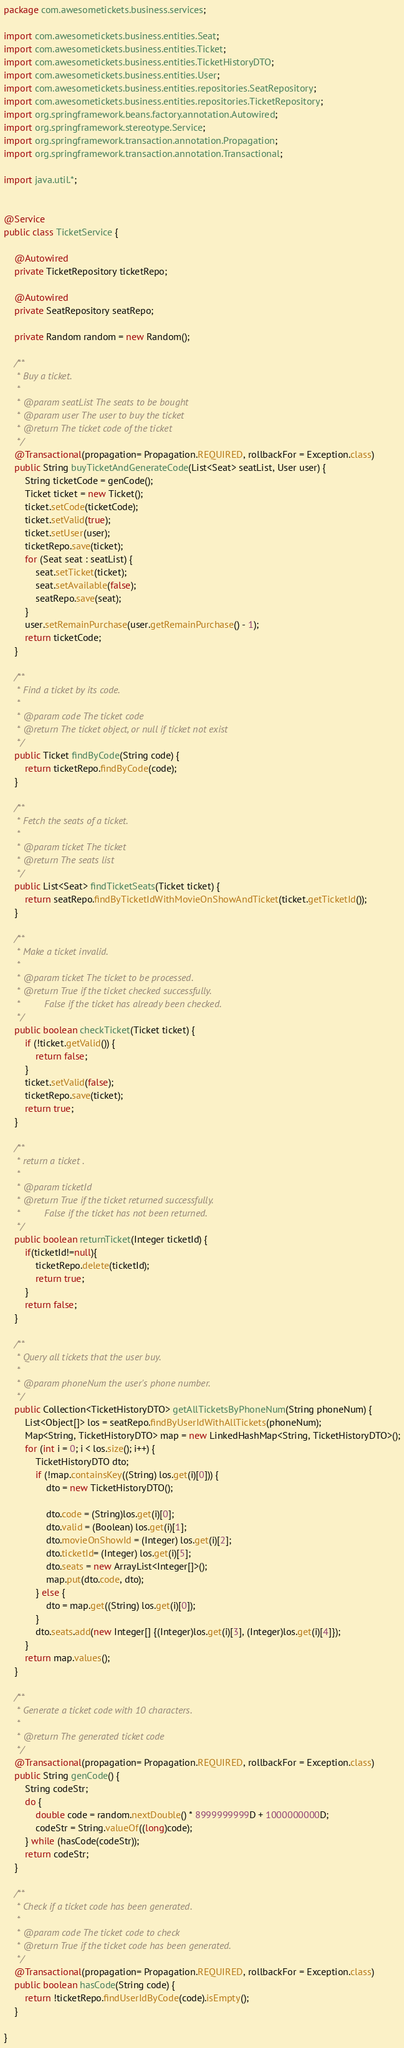Convert code to text. <code><loc_0><loc_0><loc_500><loc_500><_Java_>package com.awesometickets.business.services;

import com.awesometickets.business.entities.Seat;
import com.awesometickets.business.entities.Ticket;
import com.awesometickets.business.entities.TicketHistoryDTO;
import com.awesometickets.business.entities.User;
import com.awesometickets.business.entities.repositories.SeatRepository;
import com.awesometickets.business.entities.repositories.TicketRepository;
import org.springframework.beans.factory.annotation.Autowired;
import org.springframework.stereotype.Service;
import org.springframework.transaction.annotation.Propagation;
import org.springframework.transaction.annotation.Transactional;

import java.util.*;


@Service
public class TicketService {

    @Autowired
    private TicketRepository ticketRepo;

    @Autowired
    private SeatRepository seatRepo;

    private Random random = new Random();

    /**
     * Buy a ticket.
     *
     * @param seatList The seats to be bought
     * @param user The user to buy the ticket
     * @return The ticket code of the ticket
     */
    @Transactional(propagation= Propagation.REQUIRED, rollbackFor = Exception.class)
    public String buyTicketAndGenerateCode(List<Seat> seatList, User user) {
        String ticketCode = genCode();
        Ticket ticket = new Ticket();
        ticket.setCode(ticketCode);
        ticket.setValid(true);
        ticket.setUser(user);
        ticketRepo.save(ticket);
        for (Seat seat : seatList) {
            seat.setTicket(ticket);
            seat.setAvailable(false);
            seatRepo.save(seat);
        }
        user.setRemainPurchase(user.getRemainPurchase() - 1);
        return ticketCode;
    }

    /**
     * Find a ticket by its code.
     *
     * @param code The ticket code
     * @return The ticket object, or null if ticket not exist
     */
    public Ticket findByCode(String code) {
        return ticketRepo.findByCode(code);
    }

    /**
     * Fetch the seats of a ticket.
     *
     * @param ticket The ticket
     * @return The seats list
     */
    public List<Seat> findTicketSeats(Ticket ticket) {
        return seatRepo.findByTicketIdWithMovieOnShowAndTicket(ticket.getTicketId());
    }

    /**
     * Make a ticket invalid.
     *
     * @param ticket The ticket to be processed.
     * @return True if the ticket checked successfully.
     *         False if the ticket has already been checked.
     */
    public boolean checkTicket(Ticket ticket) {
        if (!ticket.getValid()) {
            return false;
        }
        ticket.setValid(false);
        ticketRepo.save(ticket);
        return true;
    }

    /**
     * return a ticket .
     *
     * @param ticketId
     * @return True if the ticket returned successfully.
     *         False if the ticket has not been returned.
     */
    public boolean returnTicket(Integer ticketId) {
        if(ticketId!=null){
            ticketRepo.delete(ticketId);
            return true;
        }
        return false;
    }

    /**
     * Query all tickets that the user buy.
     *
     * @param phoneNum the user's phone number.
     */
    public Collection<TicketHistoryDTO> getAllTicketsByPhoneNum(String phoneNum) {
        List<Object[]> los = seatRepo.findByUserIdWithAllTickets(phoneNum);
        Map<String, TicketHistoryDTO> map = new LinkedHashMap<String, TicketHistoryDTO>();
        for (int i = 0; i < los.size(); i++) {
            TicketHistoryDTO dto;
            if (!map.containsKey((String) los.get(i)[0])) {
                dto = new TicketHistoryDTO();

                dto.code = (String)los.get(i)[0];
                dto.valid = (Boolean) los.get(i)[1];
                dto.movieOnShowId = (Integer) los.get(i)[2];
                dto.ticketId= (Integer) los.get(i)[5];
                dto.seats = new ArrayList<Integer[]>();
                map.put(dto.code, dto);
            } else {
                dto = map.get((String) los.get(i)[0]);
            }
            dto.seats.add(new Integer[] {(Integer)los.get(i)[3], (Integer)los.get(i)[4]});
        }
        return map.values();
    }

    /**
     * Generate a ticket code with 10 characters.
     *
     * @return The generated ticket code
     */
    @Transactional(propagation= Propagation.REQUIRED, rollbackFor = Exception.class)
    public String genCode() {
        String codeStr;
        do {
            double code = random.nextDouble() * 8999999999D + 1000000000D;
            codeStr = String.valueOf((long)code);
        } while (hasCode(codeStr));
        return codeStr;
    }

    /**
     * Check if a ticket code has been generated.
     *
     * @param code The ticket code to check
     * @return True if the ticket code has been generated.
     */
    @Transactional(propagation= Propagation.REQUIRED, rollbackFor = Exception.class)
    public boolean hasCode(String code) {
        return !ticketRepo.findUserIdByCode(code).isEmpty();
    }

}
</code> 